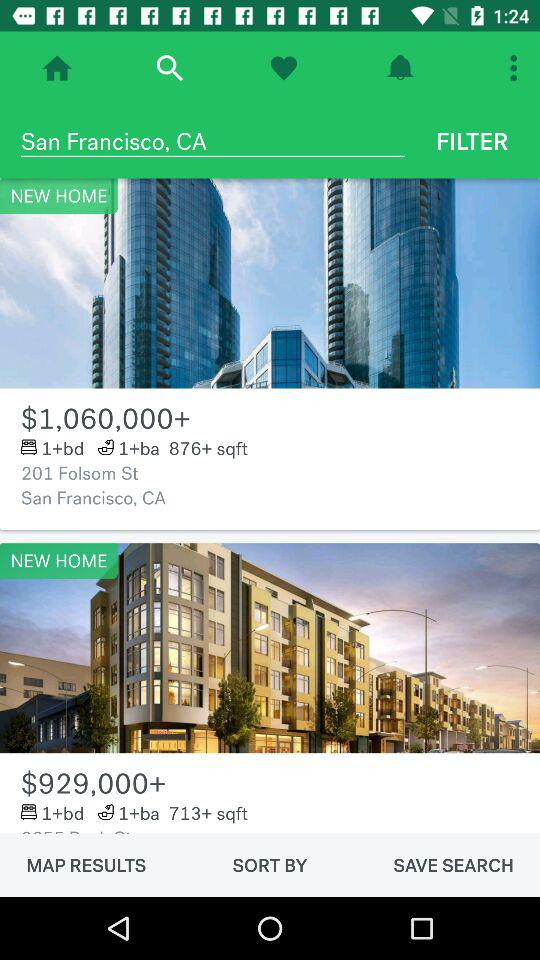What is the cost of a 1-bedroom, 1-bathroom, 876-square-foot home? The cost is $1,060,000+. 